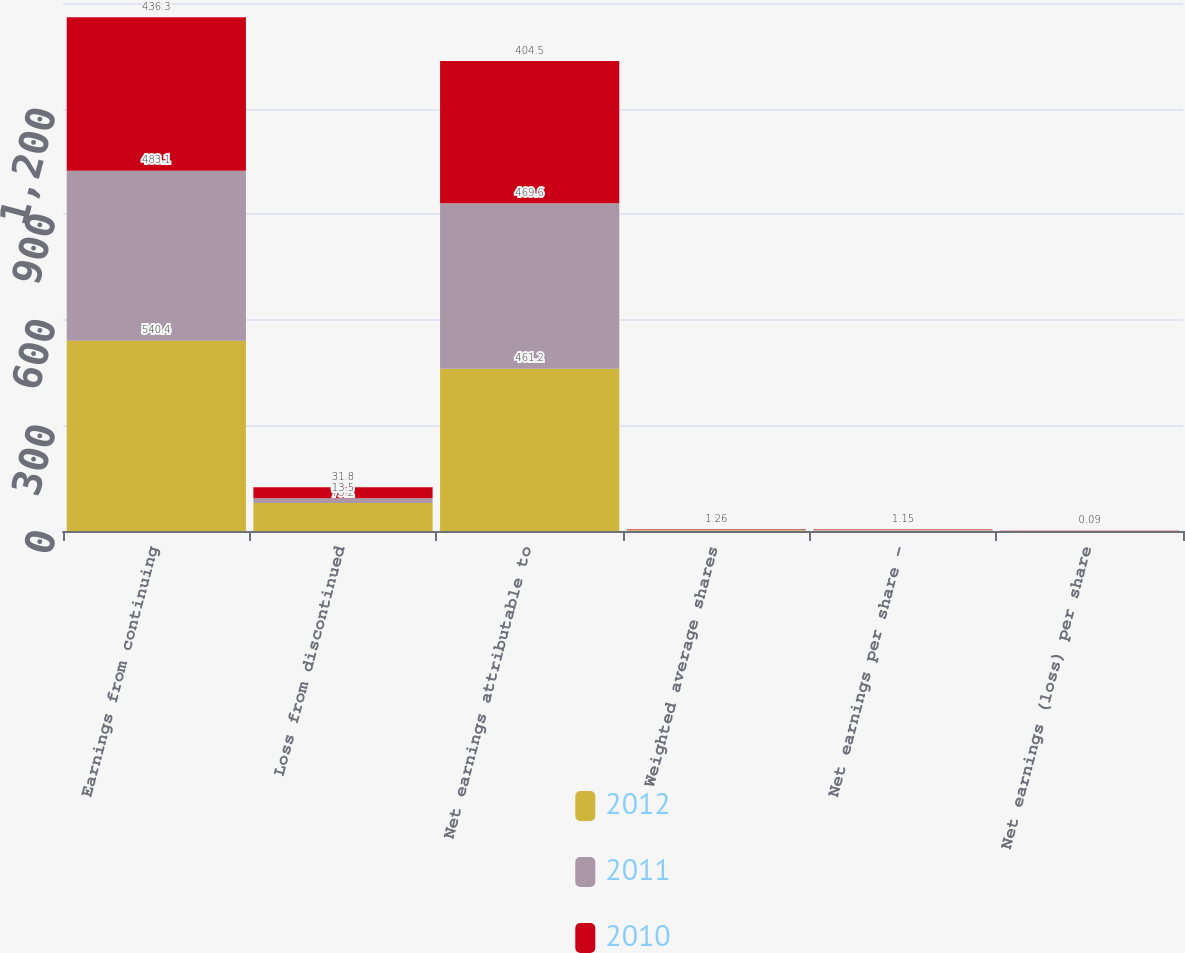Convert chart to OTSL. <chart><loc_0><loc_0><loc_500><loc_500><stacked_bar_chart><ecel><fcel>Earnings from continuing<fcel>Loss from discontinued<fcel>Net earnings attributable to<fcel>Weighted average shares<fcel>Net earnings per share -<fcel>Net earnings (loss) per share<nl><fcel>2012<fcel>540.4<fcel>79.2<fcel>461.2<fcel>1.85<fcel>1.55<fcel>0.27<nl><fcel>2011<fcel>483.1<fcel>13.5<fcel>469.6<fcel>1.61<fcel>1.53<fcel>0.04<nl><fcel>2010<fcel>436.3<fcel>31.8<fcel>404.5<fcel>1.26<fcel>1.15<fcel>0.09<nl></chart> 